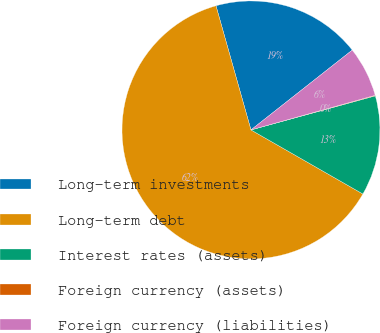<chart> <loc_0><loc_0><loc_500><loc_500><pie_chart><fcel>Long-term investments<fcel>Long-term debt<fcel>Interest rates (assets)<fcel>Foreign currency (assets)<fcel>Foreign currency (liabilities)<nl><fcel>18.75%<fcel>62.36%<fcel>12.53%<fcel>0.07%<fcel>6.3%<nl></chart> 